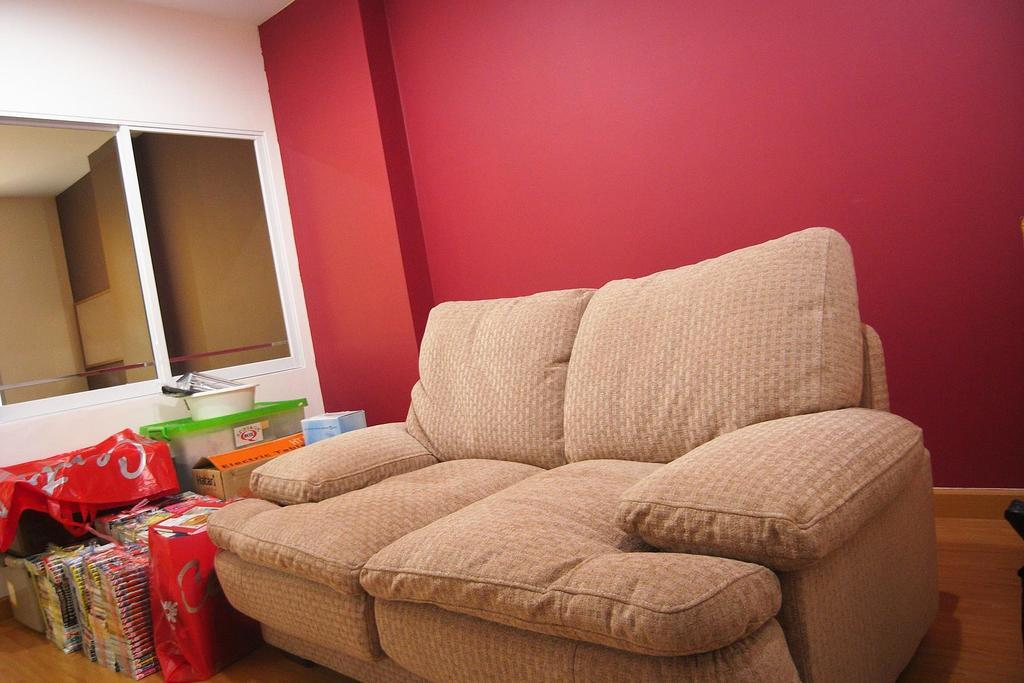What type of furniture is present in the image? There is a sofa in the image. What color is the wall behind the sofa? The wall behind the sofa is red. What can be found beside the sofa? There are covers for keeping books and boxes beside the sofa. How many quince are being steamed on the sofa in the image? There are no quince or any indication of steaming in the image. 